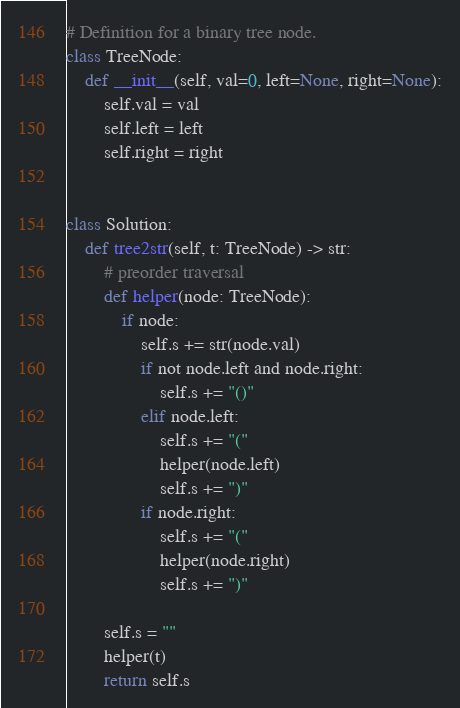Convert code to text. <code><loc_0><loc_0><loc_500><loc_500><_Python_># Definition for a binary tree node.
class TreeNode:
    def __init__(self, val=0, left=None, right=None):
        self.val = val
        self.left = left
        self.right = right


class Solution:
    def tree2str(self, t: TreeNode) -> str:
        # preorder traversal
        def helper(node: TreeNode):
            if node:
                self.s += str(node.val)
                if not node.left and node.right:
                    self.s += "()"
                elif node.left:
                    self.s += "("
                    helper(node.left)
                    self.s += ")"
                if node.right:
                    self.s += "("
                    helper(node.right)
                    self.s += ")"

        self.s = ""
        helper(t)
        return self.s
</code> 